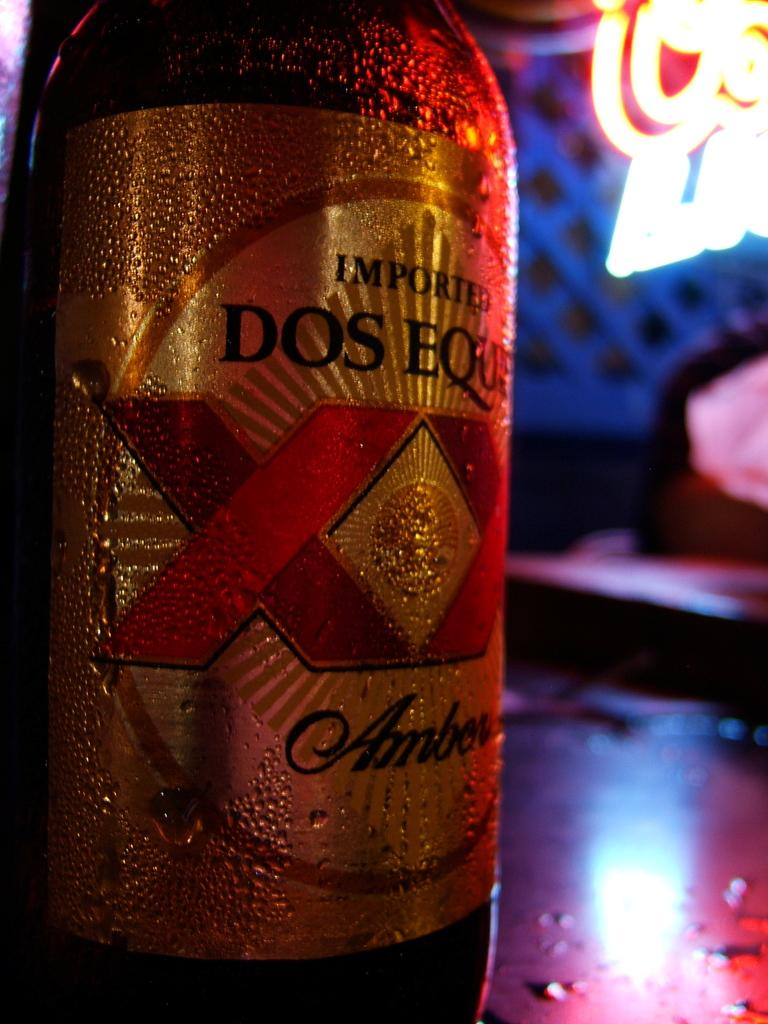<image>
Provide a brief description of the given image. A bottle of Dos Equis beer lies on a table in a bar. 